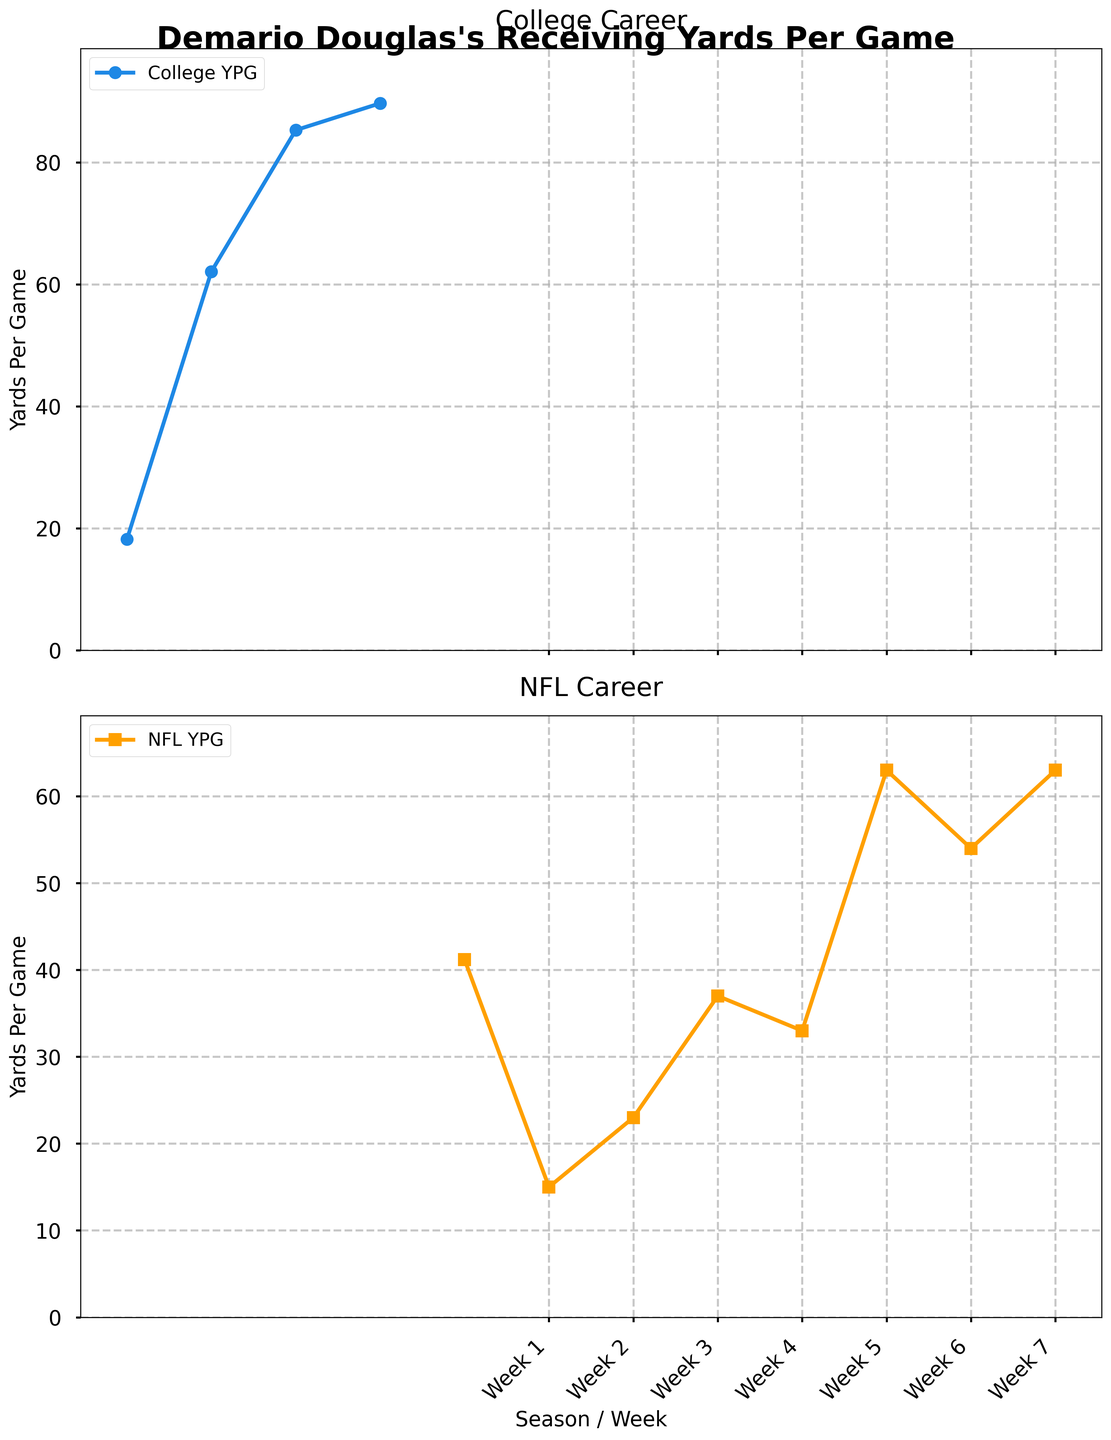How many total seasons of college football did Demario Douglas play as shown in the figure? By looking at the first subplot titled "College Career," we can count the number of data points (years) represented on the line plot. There are data points for 2019, 2020, 2021, and 2022.
Answer: 4 What is the highest number of yards per game in Demario Douglas's college career? In the "College Career" subplot, the highest YPG data point appears at the year 2022, which is 89.7 yards per game.
Answer: 89.7 What trend do you observe in Demario Douglas's receiving yards per game from his college to NFL career? In the "College Career" subplot, "Yards Per Game" increases from 2019 to 2022. In the "NFL Career" subplot, "Yards Per Game" starts at 15 yards in Week 1 and shows an increasing trend with fluctuations until Week 7. Overall, both parts show an upward trend with increased effort in both college and early NFL career.
Answer: Upward trend Comparing Week 5 and Week 6 in the NFL career, which week had more receiving yards per game? In the "NFL Career" subplot, Week 5 shows 63 yards per game, and Week 6 shows 54 yards per game. By comparing both, Week 5 had more receiving yards per game.
Answer: Week 5 What is the difference in Demario Douglas's receiving yards per game between Week 7 and Week 1 of his NFL career? The "NFL Career" subplot shows Demario Douglas's Week 1 receiving yards as 15 and Week 7 receiving yards as 63. The difference can be calculated as 63 - 15.
Answer: 48 On average, how many receiving yards per game did Demario Douglas achieve in Weeks 1 to 7 of his NFL career? To find the average YPG for Weeks 1 to 7: (15 + 23 + 37 + 33 + 63 + 54 + 63) / 7 = 41.14 yards per game.
Answer: 41.14 In which year did Demario Douglas experience the most significant increase in receiving yards per game during his college career? By examining the years in the "College Career" subplot, the most substantial increase appears between 2019 (18.2) and 2020 (62.1). The increase is 62.1 - 18.2.
Answer: 2020 Was there any week where Demario Douglas had exactly the same number of receiving yards per game in his NFL career? By observing the "NFL Career" subplot, Week 5 and Week 7 both show receiving yards per game as 63.
Answer: Yes During Demario Douglas's college career, which two consecutive years show the least improvement in receiving yards per game? In the "College Career" subplot, the change in YPG between each year needs to be calculated: 2020-2019 (43.9), 2021-2020 (23.2), 2022-2021 (4.4). The smallest increase is between 2021 and 2022.
Answer: 2021-2022 What is the total sum of receiving yards per game for Demario Douglas in his first three weeks of his NFL career? In the "NFL Career" subplot, the receiving yards per game for the first three weeks are 15, 23, and 37. The sum is 15 + 23 + 37 = 75.
Answer: 75 